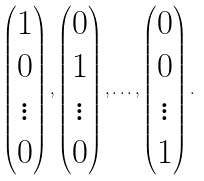<formula> <loc_0><loc_0><loc_500><loc_500>\begin{pmatrix} 1 \\ 0 \\ \vdots \\ 0 \end{pmatrix} , \begin{pmatrix} 0 \\ 1 \\ \vdots \\ 0 \end{pmatrix} , \dots , \begin{pmatrix} 0 \\ 0 \\ \vdots \\ 1 \end{pmatrix} .</formula> 